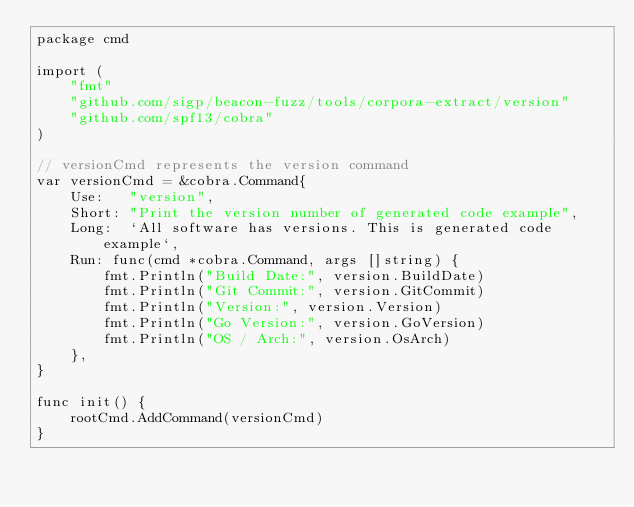<code> <loc_0><loc_0><loc_500><loc_500><_Go_>package cmd

import (
	"fmt"
	"github.com/sigp/beacon-fuzz/tools/corpora-extract/version"
	"github.com/spf13/cobra"
)

// versionCmd represents the version command
var versionCmd = &cobra.Command{
	Use:   "version",
	Short: "Print the version number of generated code example",
	Long:  `All software has versions. This is generated code example`,
	Run: func(cmd *cobra.Command, args []string) {
		fmt.Println("Build Date:", version.BuildDate)
		fmt.Println("Git Commit:", version.GitCommit)
		fmt.Println("Version:", version.Version)
		fmt.Println("Go Version:", version.GoVersion)
		fmt.Println("OS / Arch:", version.OsArch)
	},
}

func init() {
	rootCmd.AddCommand(versionCmd)
}
</code> 